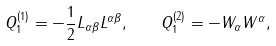Convert formula to latex. <formula><loc_0><loc_0><loc_500><loc_500>Q ^ { ( 1 ) } _ { 1 } = - \frac { 1 } { 2 } L _ { \alpha \beta } L ^ { \alpha \beta } , \quad Q ^ { ( 2 ) } _ { 1 } = - W _ { \alpha } W ^ { \alpha } ,</formula> 